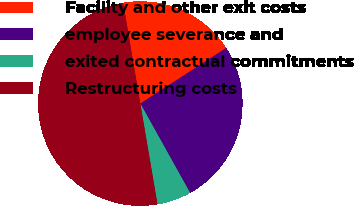Convert chart. <chart><loc_0><loc_0><loc_500><loc_500><pie_chart><fcel>Facility and other exit costs<fcel>employee severance and<fcel>exited contractual commitments<fcel>Restructuring costs<nl><fcel>18.54%<fcel>26.06%<fcel>5.4%<fcel>50.0%<nl></chart> 